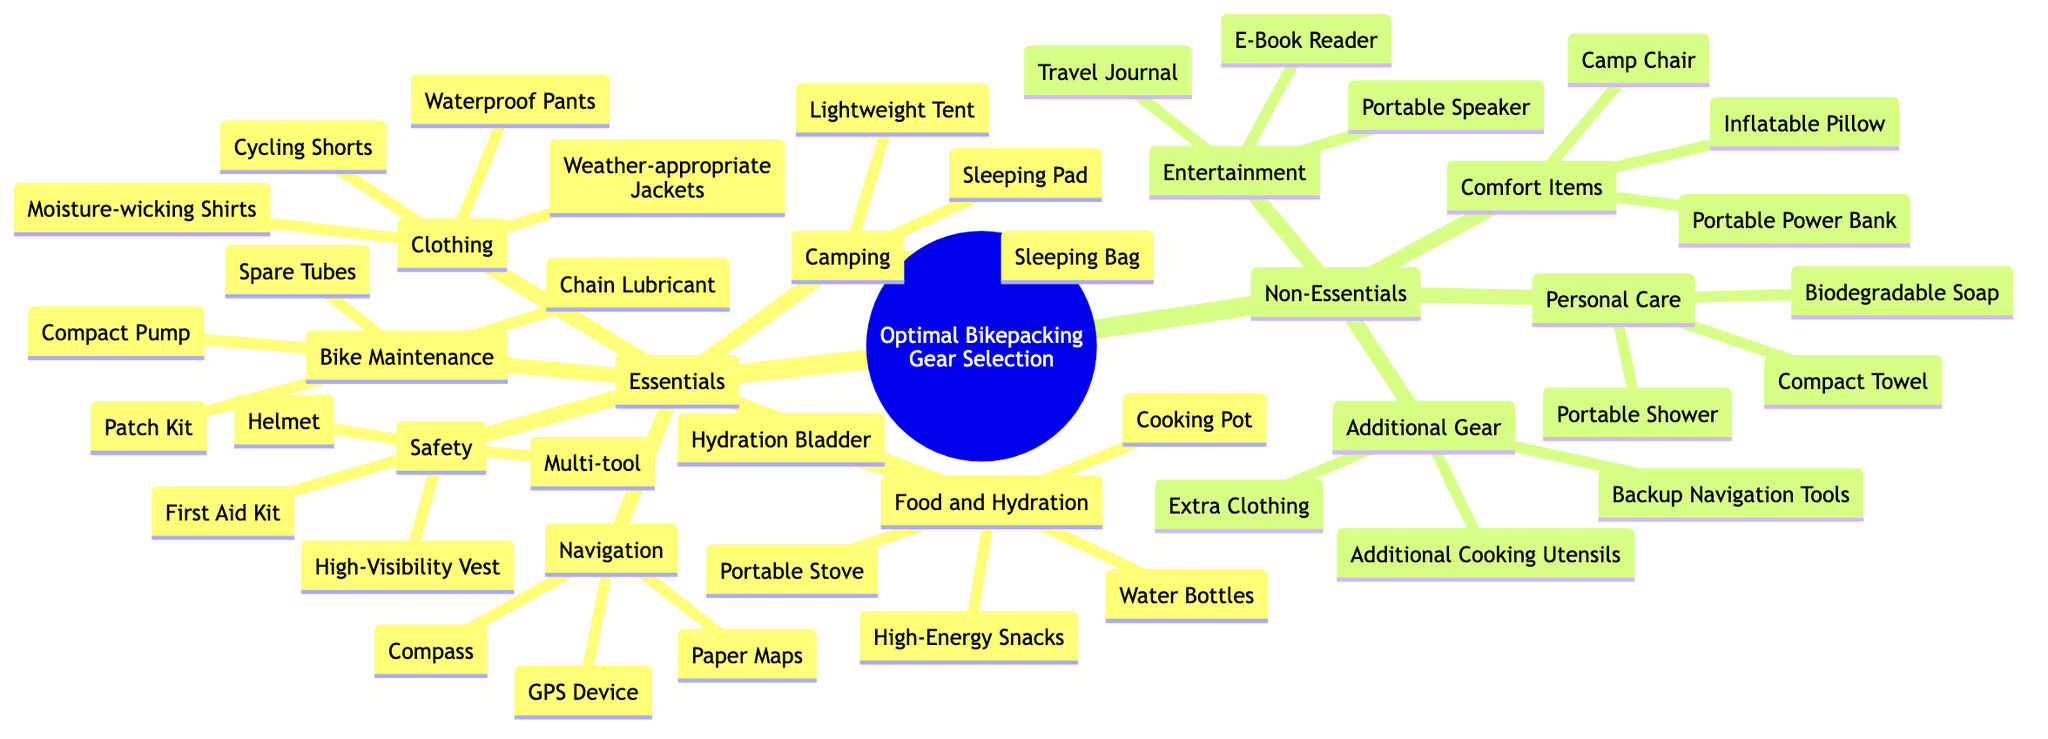What are three types of gear included under Essentials? The diagram shows that Essentials is divided into several categories, including Navigation, Safety, Camping, Clothing, Food and Hydration, and Bike Maintenance. Three types from these categories are GPS Device, First Aid Kit, and Lightweight Tent.
Answer: Navigation, Safety, Camping How many items are listed under Food and Hydration? In the Essentials section, under Food and Hydration, there are five items: Water Bottles, Hydration Bladder, High-Energy Snacks, Portable Stove, and Cooking Pot. Counting these gives a total of five items.
Answer: 5 What is an example of a Comfort Item? The diagram categorizes Non-Essentials into several groups, one of which is Comfort Items. An example provided in this category is Camp Chair.
Answer: Camp Chair Are there more Essential or Non-Essential gear items? In the diagram, Essentials contains six categories and a total of 23 items, while Non-Essentials have four categories with a total of 9 items. Since 23 is greater than 9, Essentials have more items than Non-Essentials.
Answer: Essentials What gear falls under the Clothing category? Looking at the Essentials section, the Clothing category includes Weather-appropriate Jackets, Cycling Shorts, Moisture-wicking Shirts, and Waterproof Pants, making up the items listed under the Clothing gear.
Answer: Weather-appropriate Jackets, Cycling Shorts, Moisture-wicking Shirts, Waterproof Pants What is the relationship between Camping and Safety gear in the diagram? The diagram places both Camping and Safety under the parent category of Essentials, indicating they are part of the overall necessary gear for bikepacking. Both categories contain items crucial for a successful bikepacking trip, showing their relationship as equally important aspects.
Answer: Both are under Essentials Which Non-Essential category has the most items listed? The diagram reveals that the Non-Essential categories are Comfort Items, Entertainment, Personal Care, and Additional Gear. The Comfort Items group has three items, Entertainment and Personal Care each have three items, while Additional Gear has three items. They all are equal, with none having the most items separately.
Answer: Equal How many items are classified under Bike Maintenance? Under the Essentials category, the Bike Maintenance section includes four specific items: Patch Kit, Compact Pump, Spare Tubes, and Chain Lubricant, leading to a total of four maintenance items.
Answer: 4 